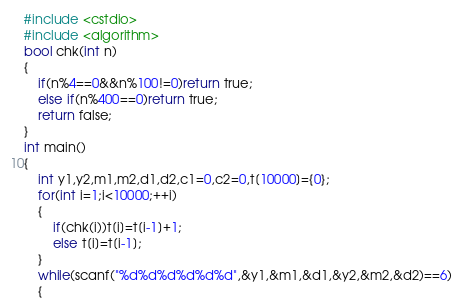Convert code to text. <code><loc_0><loc_0><loc_500><loc_500><_C++_>#include <cstdio>
#include <algorithm>
bool chk(int n)
{
    if(n%4==0&&n%100!=0)return true;
    else if(n%400==0)return true;
    return false;
}
int main()
{
    int y1,y2,m1,m2,d1,d2,c1=0,c2=0,t[10000]={0};
    for(int i=1;i<10000;++i)
    {
        if(chk(i))t[i]=t[i-1]+1;
        else t[i]=t[i-1];
    }
    while(scanf("%d%d%d%d%d%d",&y1,&m1,&d1,&y2,&m2,&d2)==6)
    {</code> 